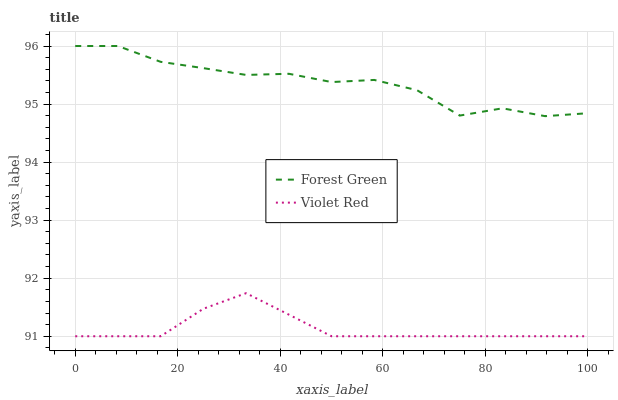Does Violet Red have the minimum area under the curve?
Answer yes or no. Yes. Does Forest Green have the maximum area under the curve?
Answer yes or no. Yes. Does Violet Red have the maximum area under the curve?
Answer yes or no. No. Is Violet Red the smoothest?
Answer yes or no. Yes. Is Forest Green the roughest?
Answer yes or no. Yes. Is Violet Red the roughest?
Answer yes or no. No. Does Violet Red have the lowest value?
Answer yes or no. Yes. Does Forest Green have the highest value?
Answer yes or no. Yes. Does Violet Red have the highest value?
Answer yes or no. No. Is Violet Red less than Forest Green?
Answer yes or no. Yes. Is Forest Green greater than Violet Red?
Answer yes or no. Yes. Does Violet Red intersect Forest Green?
Answer yes or no. No. 